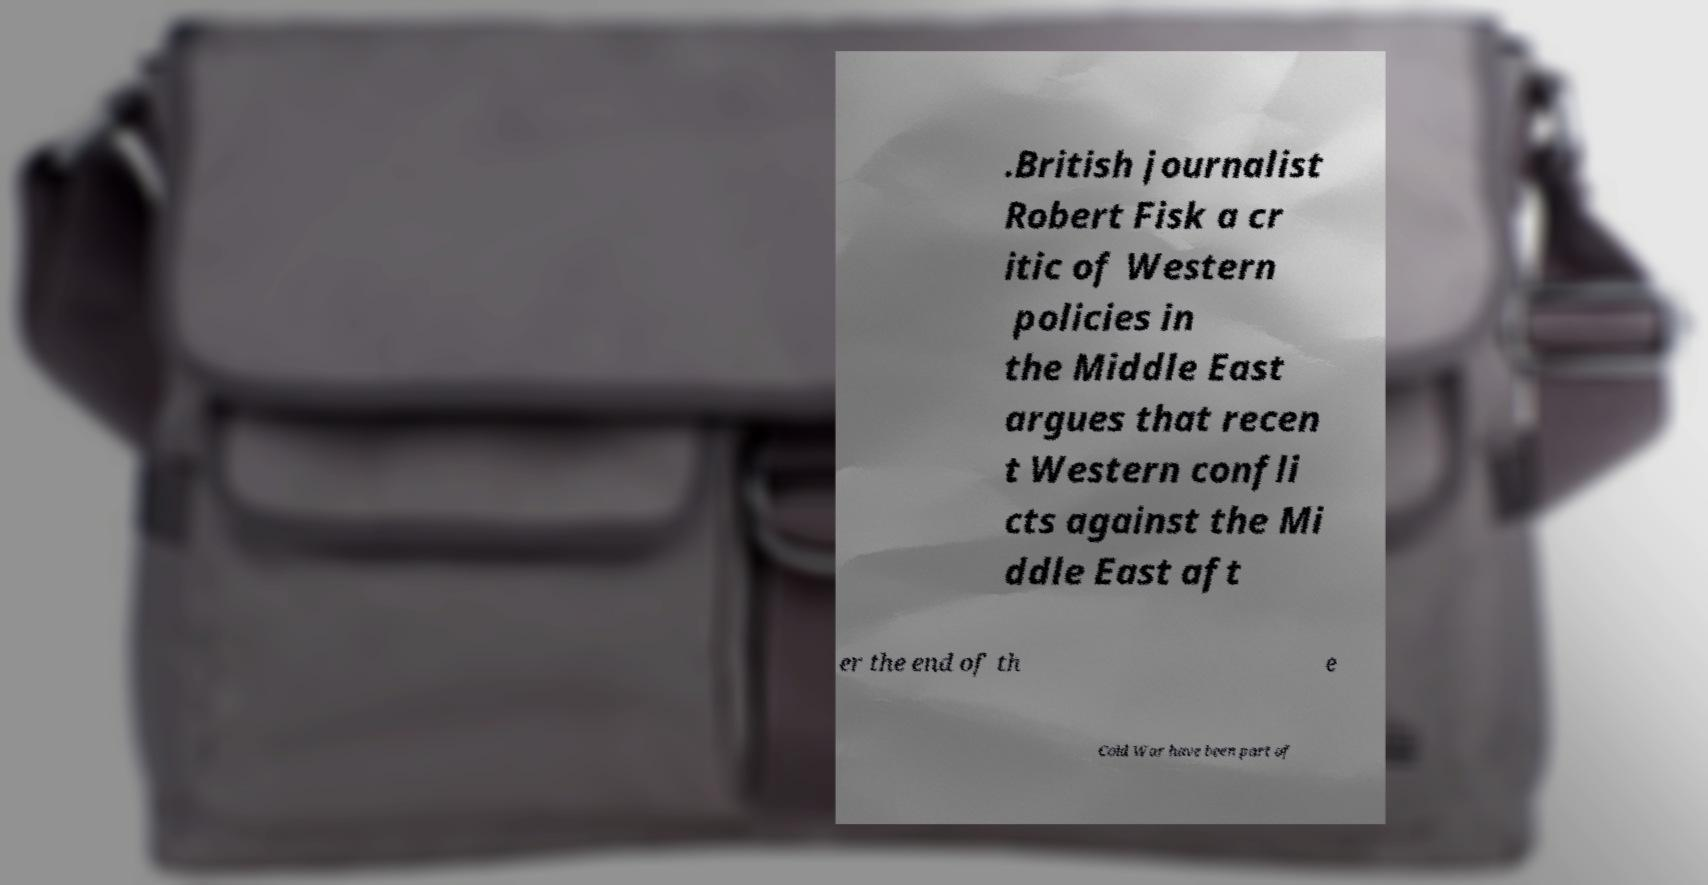Can you read and provide the text displayed in the image?This photo seems to have some interesting text. Can you extract and type it out for me? .British journalist Robert Fisk a cr itic of Western policies in the Middle East argues that recen t Western confli cts against the Mi ddle East aft er the end of th e Cold War have been part of 